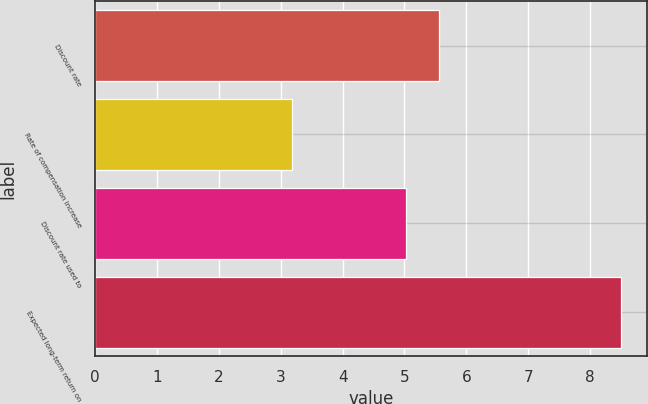<chart> <loc_0><loc_0><loc_500><loc_500><bar_chart><fcel>Discount rate<fcel>Rate of compensation increase<fcel>Discount rate used to<fcel>Expected long-term return on<nl><fcel>5.56<fcel>3.18<fcel>5.03<fcel>8.5<nl></chart> 